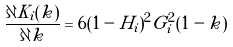Convert formula to latex. <formula><loc_0><loc_0><loc_500><loc_500>\frac { { \partial K _ { i } ( k ) } } { \partial k } = 6 ( 1 - H _ { i } ) ^ { 2 } G _ { i } ^ { 2 } ( 1 - k )</formula> 